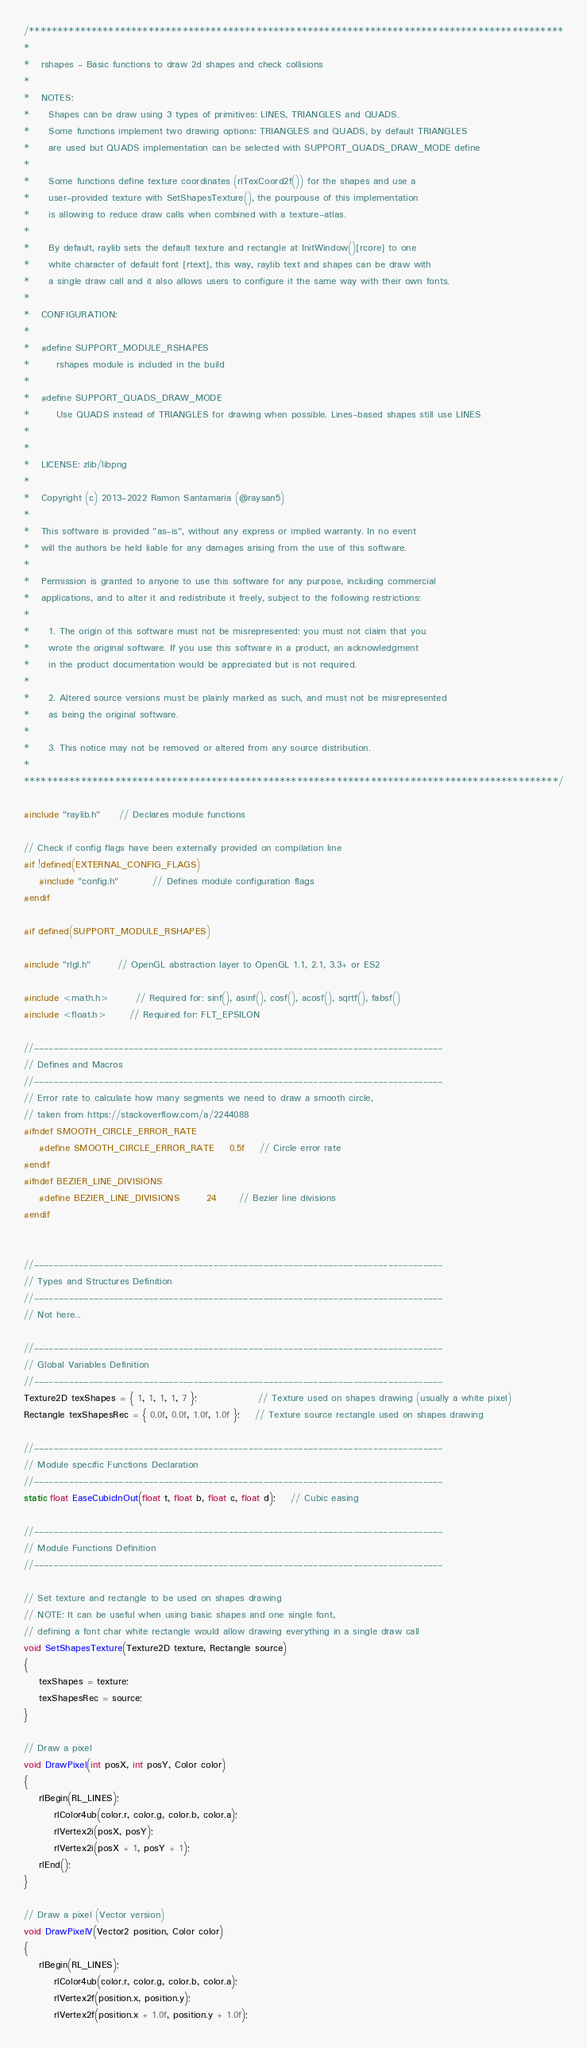Convert code to text. <code><loc_0><loc_0><loc_500><loc_500><_C_>/**********************************************************************************************
*
*   rshapes - Basic functions to draw 2d shapes and check collisions
*
*   NOTES:
*     Shapes can be draw using 3 types of primitives: LINES, TRIANGLES and QUADS.
*     Some functions implement two drawing options: TRIANGLES and QUADS, by default TRIANGLES
*     are used but QUADS implementation can be selected with SUPPORT_QUADS_DRAW_MODE define
*
*     Some functions define texture coordinates (rlTexCoord2f()) for the shapes and use a
*     user-provided texture with SetShapesTexture(), the pourpouse of this implementation
*     is allowing to reduce draw calls when combined with a texture-atlas.
*
*     By default, raylib sets the default texture and rectangle at InitWindow()[rcore] to one
*     white character of default font [rtext], this way, raylib text and shapes can be draw with
*     a single draw call and it also allows users to configure it the same way with their own fonts.
*
*   CONFIGURATION:
*
*   #define SUPPORT_MODULE_RSHAPES
*       rshapes module is included in the build
*
*   #define SUPPORT_QUADS_DRAW_MODE
*       Use QUADS instead of TRIANGLES for drawing when possible. Lines-based shapes still use LINES
*
*
*   LICENSE: zlib/libpng
*
*   Copyright (c) 2013-2022 Ramon Santamaria (@raysan5)
*
*   This software is provided "as-is", without any express or implied warranty. In no event
*   will the authors be held liable for any damages arising from the use of this software.
*
*   Permission is granted to anyone to use this software for any purpose, including commercial
*   applications, and to alter it and redistribute it freely, subject to the following restrictions:
*
*     1. The origin of this software must not be misrepresented; you must not claim that you
*     wrote the original software. If you use this software in a product, an acknowledgment
*     in the product documentation would be appreciated but is not required.
*
*     2. Altered source versions must be plainly marked as such, and must not be misrepresented
*     as being the original software.
*
*     3. This notice may not be removed or altered from any source distribution.
*
**********************************************************************************************/

#include "raylib.h"     // Declares module functions

// Check if config flags have been externally provided on compilation line
#if !defined(EXTERNAL_CONFIG_FLAGS)
    #include "config.h"         // Defines module configuration flags
#endif

#if defined(SUPPORT_MODULE_RSHAPES)

#include "rlgl.h"       // OpenGL abstraction layer to OpenGL 1.1, 2.1, 3.3+ or ES2

#include <math.h>       // Required for: sinf(), asinf(), cosf(), acosf(), sqrtf(), fabsf()
#include <float.h>      // Required for: FLT_EPSILON

//----------------------------------------------------------------------------------
// Defines and Macros
//----------------------------------------------------------------------------------
// Error rate to calculate how many segments we need to draw a smooth circle,
// taken from https://stackoverflow.com/a/2244088
#ifndef SMOOTH_CIRCLE_ERROR_RATE
    #define SMOOTH_CIRCLE_ERROR_RATE    0.5f    // Circle error rate
#endif
#ifndef BEZIER_LINE_DIVISIONS
    #define BEZIER_LINE_DIVISIONS       24      // Bezier line divisions
#endif


//----------------------------------------------------------------------------------
// Types and Structures Definition
//----------------------------------------------------------------------------------
// Not here...

//----------------------------------------------------------------------------------
// Global Variables Definition
//----------------------------------------------------------------------------------
Texture2D texShapes = { 1, 1, 1, 1, 7 };                // Texture used on shapes drawing (usually a white pixel)
Rectangle texShapesRec = { 0.0f, 0.0f, 1.0f, 1.0f };    // Texture source rectangle used on shapes drawing

//----------------------------------------------------------------------------------
// Module specific Functions Declaration
//----------------------------------------------------------------------------------
static float EaseCubicInOut(float t, float b, float c, float d);    // Cubic easing

//----------------------------------------------------------------------------------
// Module Functions Definition
//----------------------------------------------------------------------------------

// Set texture and rectangle to be used on shapes drawing
// NOTE: It can be useful when using basic shapes and one single font,
// defining a font char white rectangle would allow drawing everything in a single draw call
void SetShapesTexture(Texture2D texture, Rectangle source)
{
    texShapes = texture;
    texShapesRec = source;
}

// Draw a pixel
void DrawPixel(int posX, int posY, Color color)
{
    rlBegin(RL_LINES);
        rlColor4ub(color.r, color.g, color.b, color.a);
        rlVertex2i(posX, posY);
        rlVertex2i(posX + 1, posY + 1);
    rlEnd();
}

// Draw a pixel (Vector version)
void DrawPixelV(Vector2 position, Color color)
{
    rlBegin(RL_LINES);
        rlColor4ub(color.r, color.g, color.b, color.a);
        rlVertex2f(position.x, position.y);
        rlVertex2f(position.x + 1.0f, position.y + 1.0f);</code> 